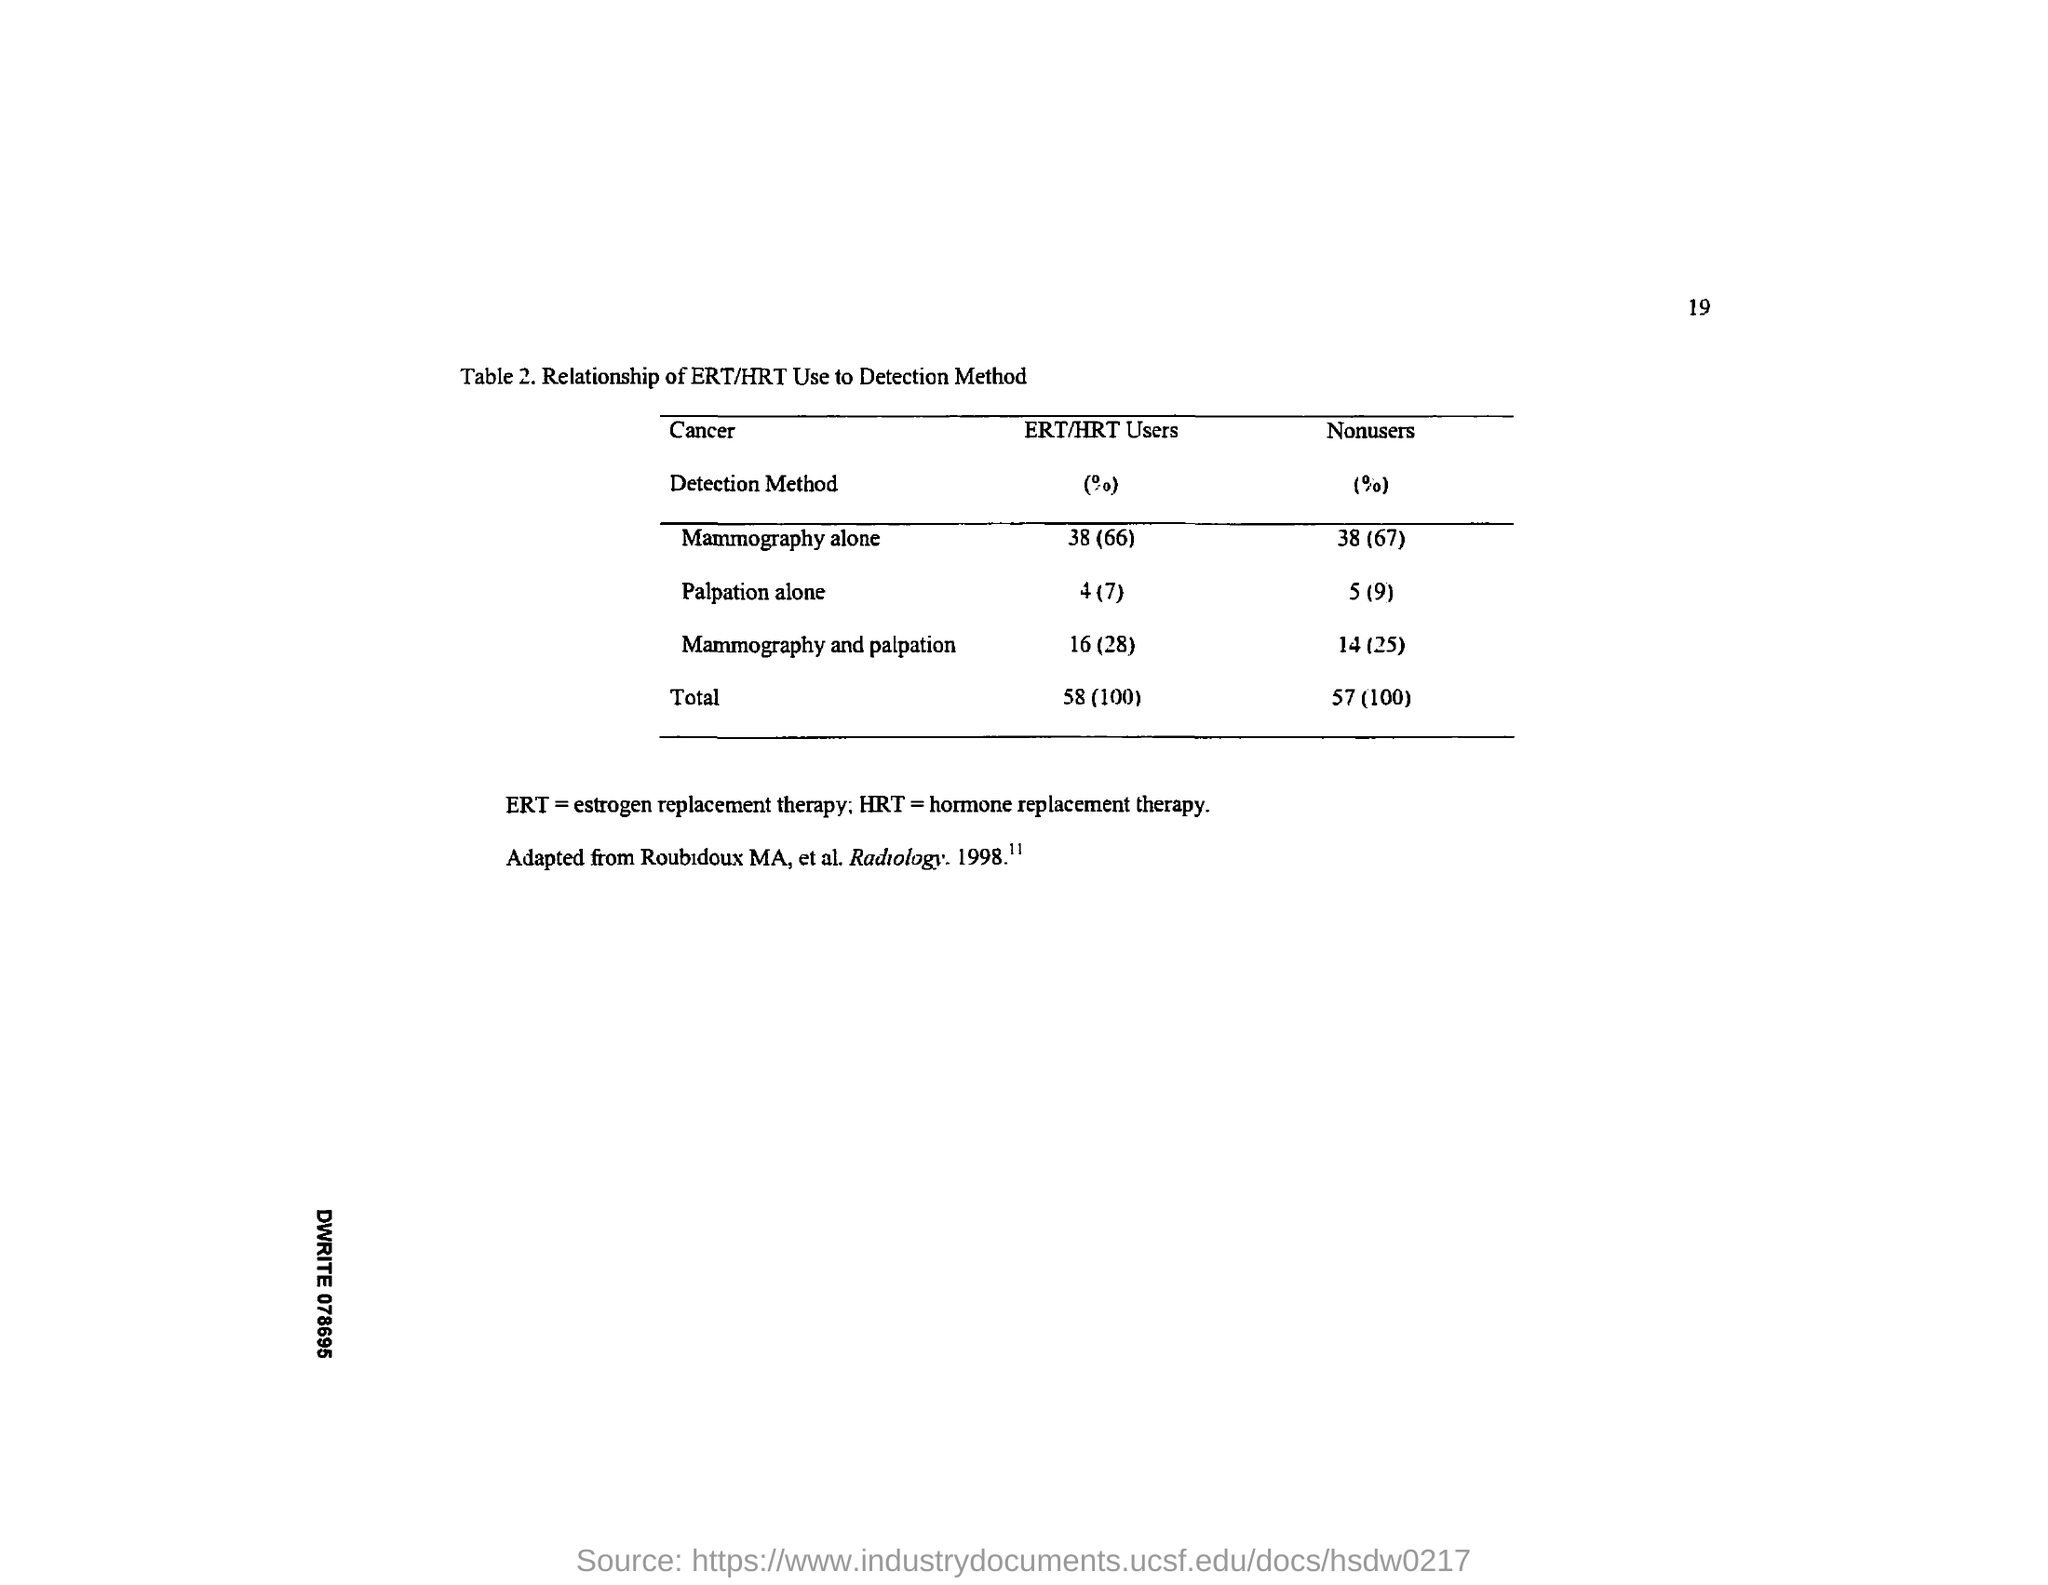What does ERT stand for?
Your answer should be very brief. Estrogen replacement therapy. What does HRT stand for?
Offer a very short reply. Hormone replacement therapy. 